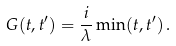Convert formula to latex. <formula><loc_0><loc_0><loc_500><loc_500>G ( t , t ^ { \prime } ) = \frac { i } { \lambda } \min ( t , t ^ { \prime } ) \, .</formula> 